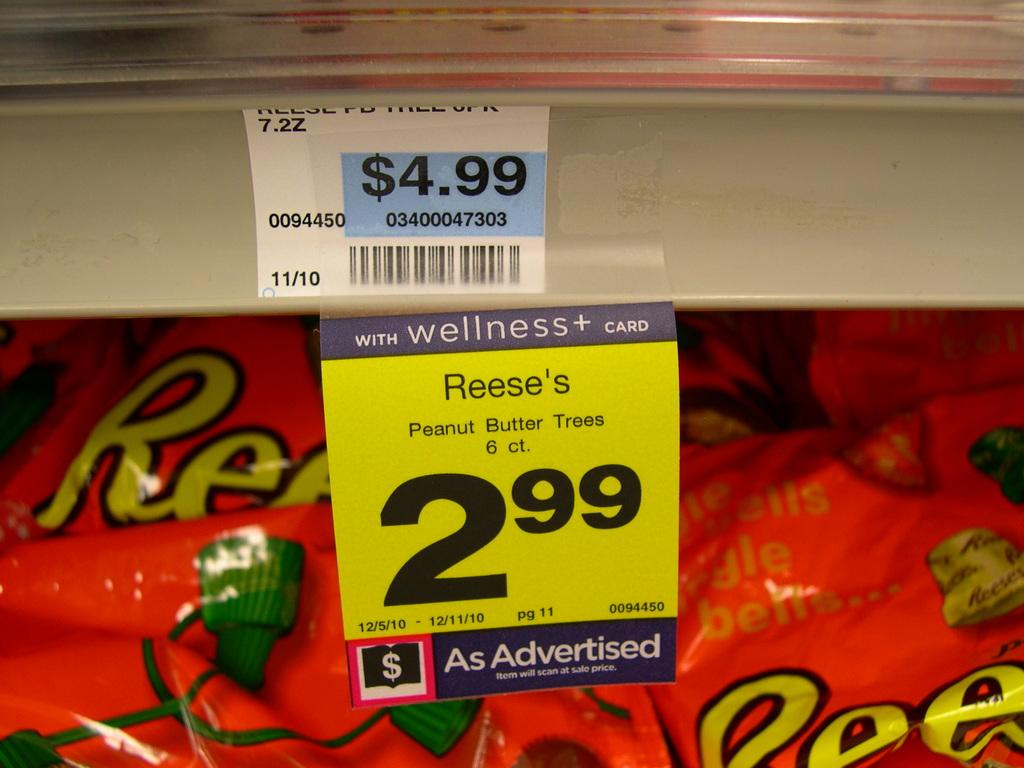What type of information is displayed in the image? There are price rates in the image. What color is the banner in the background of the image? The banner in the background of the image is red. Is there a group of people celebrating a birthday in the image? There is no group of people or any indication of a birthday celebration in the image. 